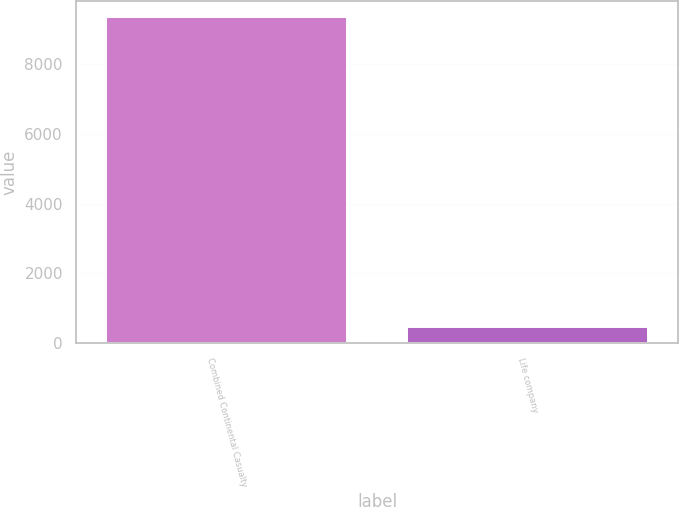Convert chart to OTSL. <chart><loc_0><loc_0><loc_500><loc_500><bar_chart><fcel>Combined Continental Casualty<fcel>Life company<nl><fcel>9338<fcel>448<nl></chart> 